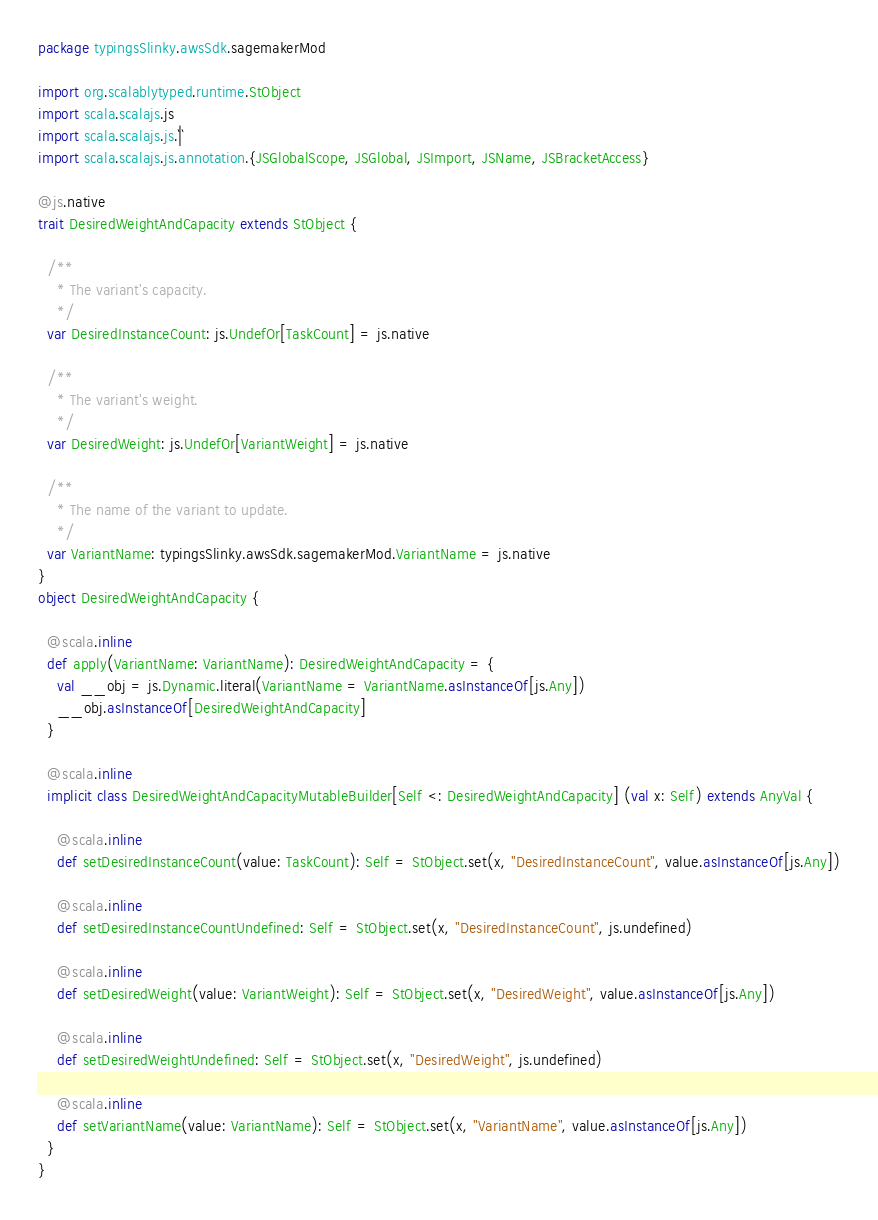<code> <loc_0><loc_0><loc_500><loc_500><_Scala_>package typingsSlinky.awsSdk.sagemakerMod

import org.scalablytyped.runtime.StObject
import scala.scalajs.js
import scala.scalajs.js.`|`
import scala.scalajs.js.annotation.{JSGlobalScope, JSGlobal, JSImport, JSName, JSBracketAccess}

@js.native
trait DesiredWeightAndCapacity extends StObject {
  
  /**
    * The variant's capacity.
    */
  var DesiredInstanceCount: js.UndefOr[TaskCount] = js.native
  
  /**
    * The variant's weight.
    */
  var DesiredWeight: js.UndefOr[VariantWeight] = js.native
  
  /**
    * The name of the variant to update.
    */
  var VariantName: typingsSlinky.awsSdk.sagemakerMod.VariantName = js.native
}
object DesiredWeightAndCapacity {
  
  @scala.inline
  def apply(VariantName: VariantName): DesiredWeightAndCapacity = {
    val __obj = js.Dynamic.literal(VariantName = VariantName.asInstanceOf[js.Any])
    __obj.asInstanceOf[DesiredWeightAndCapacity]
  }
  
  @scala.inline
  implicit class DesiredWeightAndCapacityMutableBuilder[Self <: DesiredWeightAndCapacity] (val x: Self) extends AnyVal {
    
    @scala.inline
    def setDesiredInstanceCount(value: TaskCount): Self = StObject.set(x, "DesiredInstanceCount", value.asInstanceOf[js.Any])
    
    @scala.inline
    def setDesiredInstanceCountUndefined: Self = StObject.set(x, "DesiredInstanceCount", js.undefined)
    
    @scala.inline
    def setDesiredWeight(value: VariantWeight): Self = StObject.set(x, "DesiredWeight", value.asInstanceOf[js.Any])
    
    @scala.inline
    def setDesiredWeightUndefined: Self = StObject.set(x, "DesiredWeight", js.undefined)
    
    @scala.inline
    def setVariantName(value: VariantName): Self = StObject.set(x, "VariantName", value.asInstanceOf[js.Any])
  }
}
</code> 